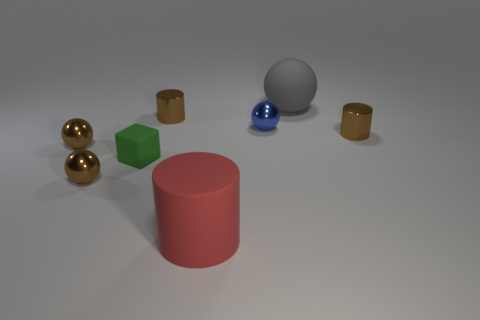There is a gray object that is behind the cube; is its shape the same as the tiny blue metallic thing?
Offer a terse response. Yes. How many red things are either big rubber objects or tiny cylinders?
Offer a very short reply. 1. Are there the same number of gray rubber things that are in front of the green matte thing and big rubber cylinders that are in front of the large gray matte ball?
Offer a very short reply. No. There is a big matte thing in front of the small brown metal cylinder that is behind the brown cylinder that is right of the small blue shiny thing; what color is it?
Your response must be concise. Red. What size is the ball in front of the tiny matte cube?
Make the answer very short. Small. There is a blue metal thing that is the same size as the green rubber thing; what is its shape?
Provide a succinct answer. Sphere. Is the large thing in front of the large gray matte sphere made of the same material as the large thing that is behind the small green object?
Provide a short and direct response. Yes. What is the large object in front of the brown metallic cylinder right of the red rubber thing made of?
Make the answer very short. Rubber. There is a sphere behind the tiny metal cylinder that is on the left side of the metallic cylinder that is to the right of the tiny blue object; what size is it?
Ensure brevity in your answer.  Large. Do the green thing and the blue metal object have the same size?
Keep it short and to the point. Yes. 